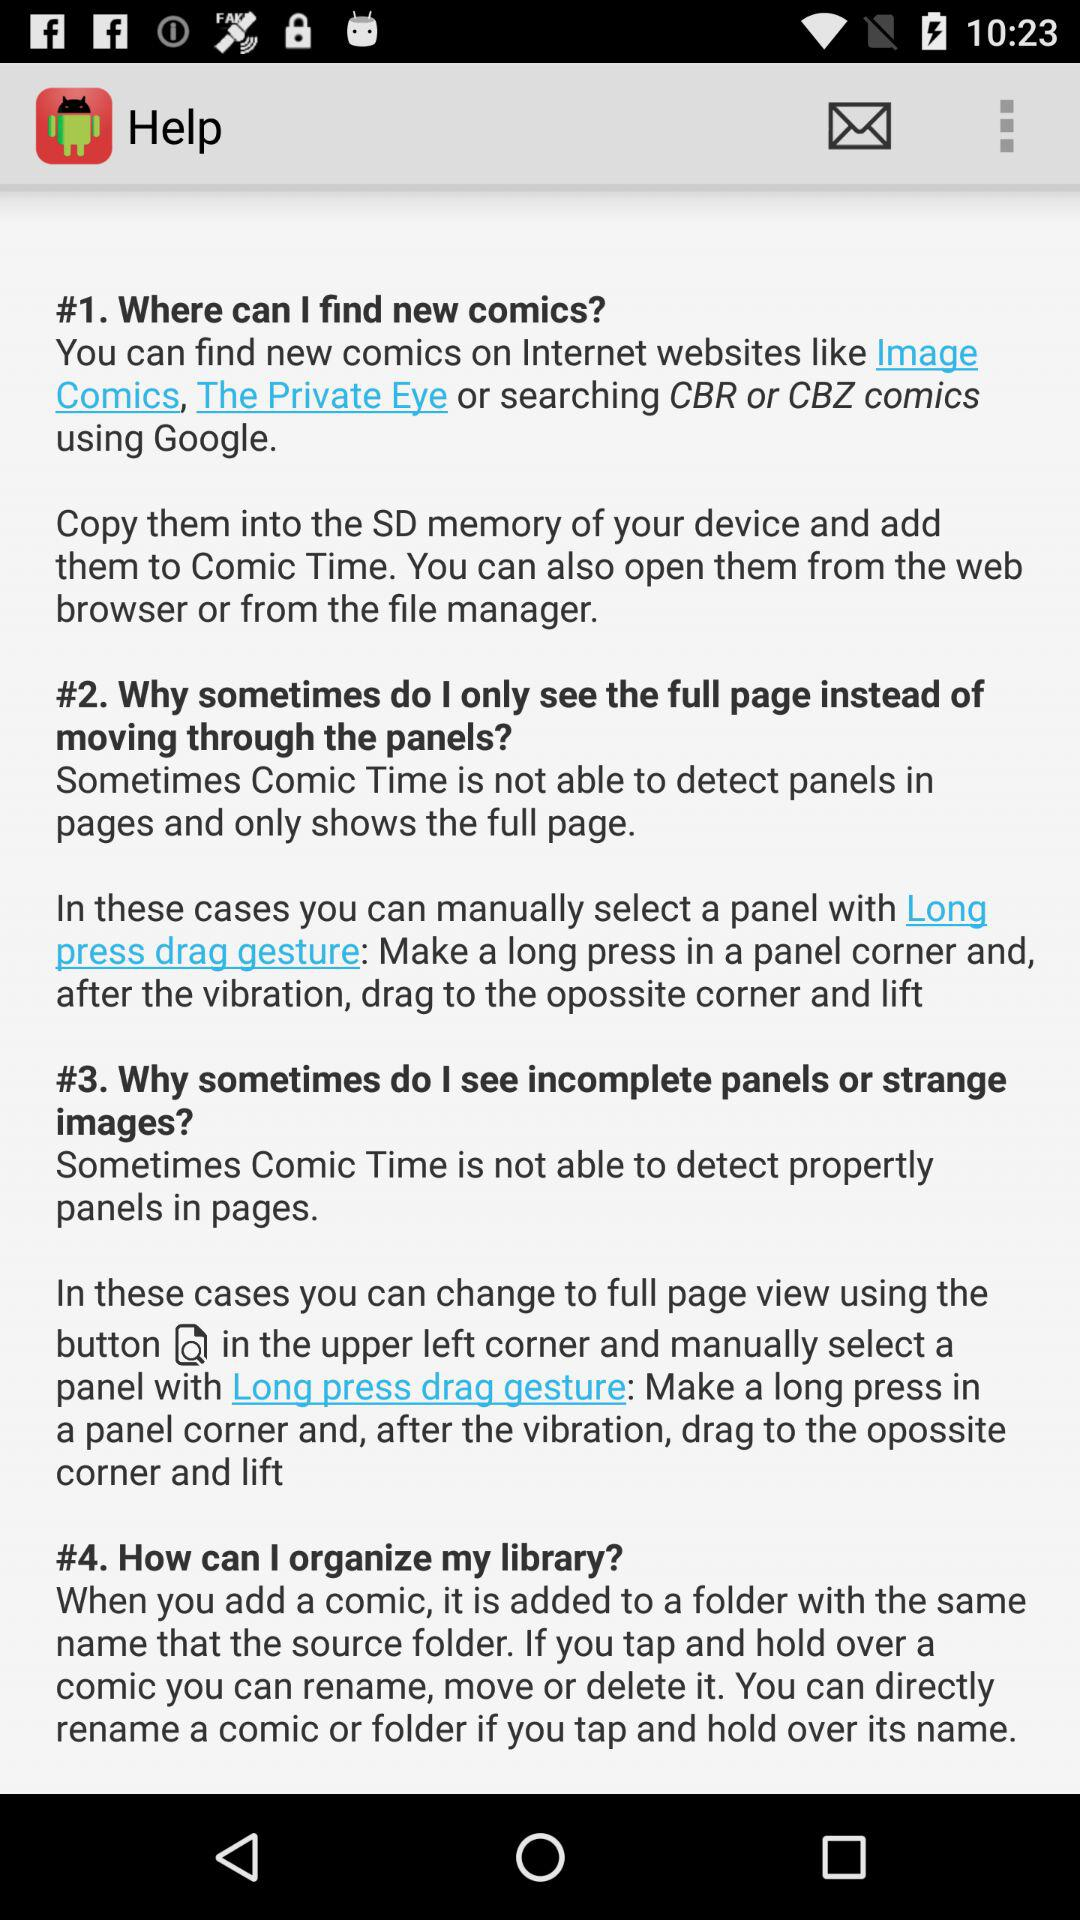How many ways are there to select a panel?
Answer the question using a single word or phrase. 2 